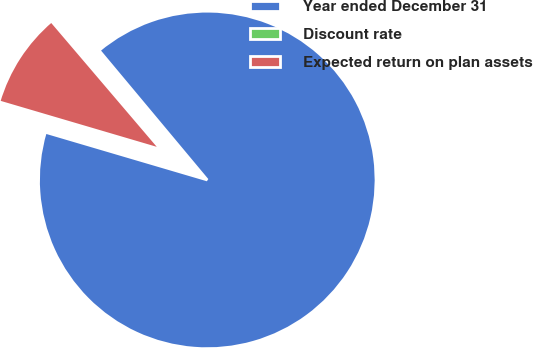Convert chart to OTSL. <chart><loc_0><loc_0><loc_500><loc_500><pie_chart><fcel>Year ended December 31<fcel>Discount rate<fcel>Expected return on plan assets<nl><fcel>90.64%<fcel>0.16%<fcel>9.21%<nl></chart> 